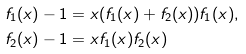Convert formula to latex. <formula><loc_0><loc_0><loc_500><loc_500>f _ { 1 } ( x ) - 1 & = x ( f _ { 1 } ( x ) + f _ { 2 } ( x ) ) f _ { 1 } ( x ) , \\ f _ { 2 } ( x ) - 1 & = x f _ { 1 } ( x ) f _ { 2 } ( x )</formula> 